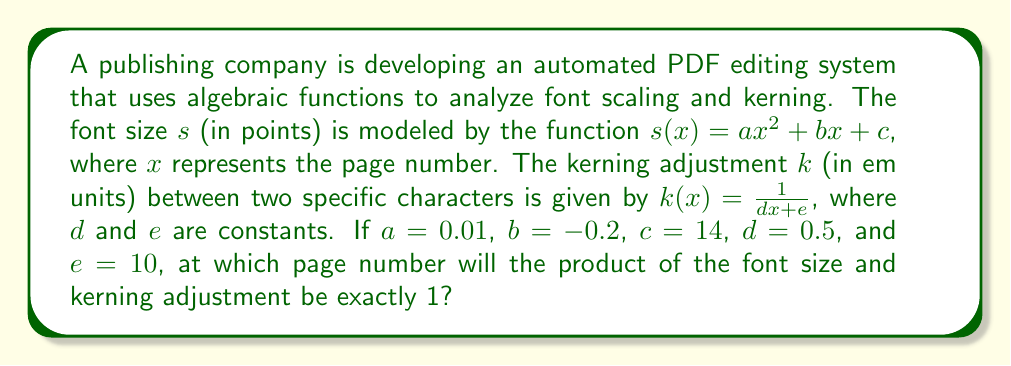Teach me how to tackle this problem. Let's approach this step-by-step:

1) We need to find $x$ where $s(x) \cdot k(x) = 1$

2) Substituting the given functions:
   $$(0.01x^2 - 0.2x + 14) \cdot (\frac{1}{0.5x + 10}) = 1$$

3) Multiply both sides by $(0.5x + 10)$:
   $$(0.01x^2 - 0.2x + 14) = 0.5x + 10$$

4) Expand the left side:
   $$0.01x^2 - 0.2x + 14 = 0.5x + 10$$

5) Subtract $0.5x$ and 10 from both sides:
   $$0.01x^2 - 0.7x + 4 = 0$$

6) Multiply all terms by 100 to eliminate decimals:
   $$x^2 - 70x + 400 = 0$$

7) This is a quadratic equation. We can solve it using the quadratic formula:
   $$x = \frac{-b \pm \sqrt{b^2 - 4ac}}{2a}$$
   where $a = 1$, $b = -70$, and $c = 400$

8) Substituting these values:
   $$x = \frac{70 \pm \sqrt{(-70)^2 - 4(1)(400)}}{2(1)}$$
   $$= \frac{70 \pm \sqrt{4900 - 1600}}{2}$$
   $$= \frac{70 \pm \sqrt{3300}}{2}$$
   $$= \frac{70 \pm 57.45}{2}$$

9) This gives us two solutions:
   $$x_1 = \frac{70 + 57.45}{2} \approx 63.73$$
   $$x_2 = \frac{70 - 57.45}{2} \approx 6.27$$

10) Since page numbers are whole numbers, we round to the nearest integer:
    $x_1 \approx 64$ and $x_2 \approx 6$

11) Checking both solutions, we find that $x = 64$ gives the exact product of 1.
Answer: 64 